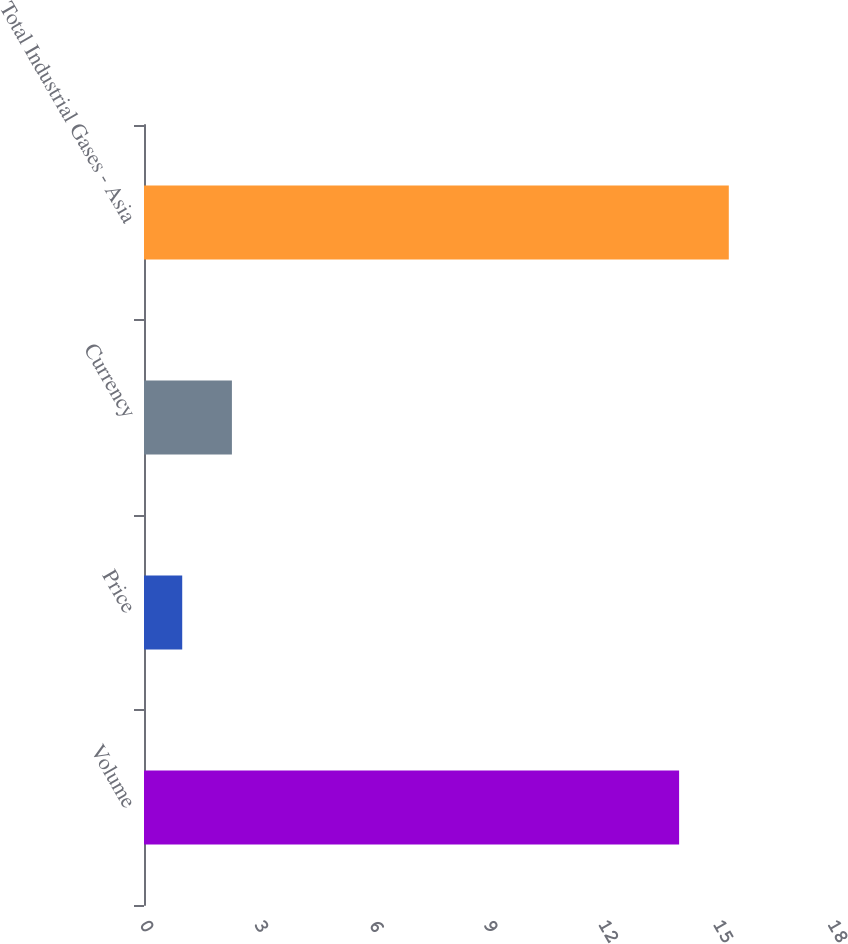Convert chart to OTSL. <chart><loc_0><loc_0><loc_500><loc_500><bar_chart><fcel>Volume<fcel>Price<fcel>Currency<fcel>Total Industrial Gases - Asia<nl><fcel>14<fcel>1<fcel>2.3<fcel>15.3<nl></chart> 